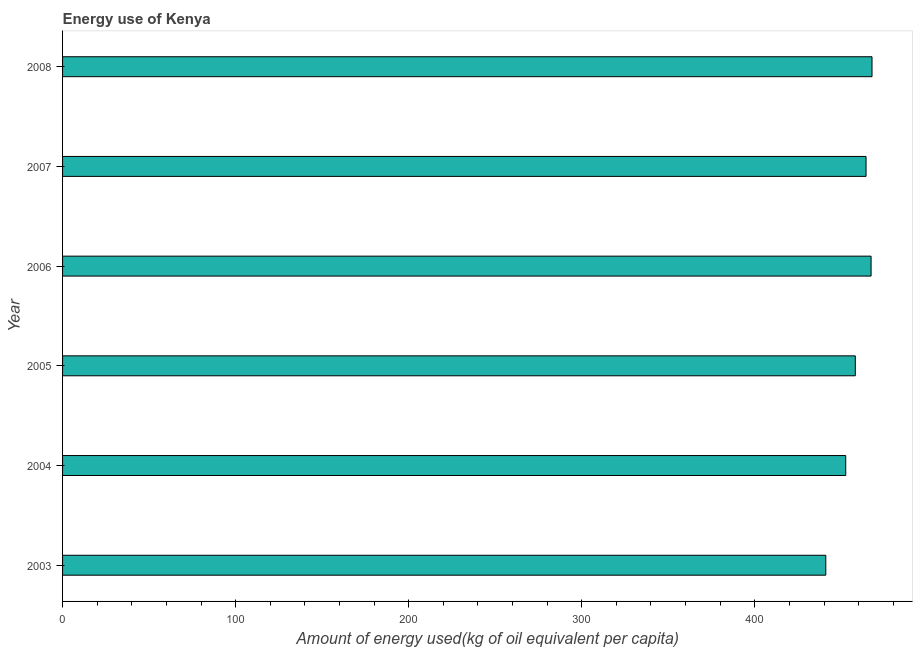What is the title of the graph?
Keep it short and to the point. Energy use of Kenya. What is the label or title of the X-axis?
Your answer should be very brief. Amount of energy used(kg of oil equivalent per capita). What is the amount of energy used in 2006?
Your answer should be very brief. 467.17. Across all years, what is the maximum amount of energy used?
Provide a short and direct response. 467.72. Across all years, what is the minimum amount of energy used?
Make the answer very short. 441.01. In which year was the amount of energy used maximum?
Your answer should be very brief. 2008. What is the sum of the amount of energy used?
Your answer should be compact. 2750.76. What is the difference between the amount of energy used in 2005 and 2008?
Ensure brevity in your answer.  -9.65. What is the average amount of energy used per year?
Offer a very short reply. 458.46. What is the median amount of energy used?
Offer a terse response. 461.17. What is the ratio of the amount of energy used in 2004 to that in 2005?
Provide a succinct answer. 0.99. Is the difference between the amount of energy used in 2003 and 2004 greater than the difference between any two years?
Your response must be concise. No. What is the difference between the highest and the second highest amount of energy used?
Your answer should be very brief. 0.55. Is the sum of the amount of energy used in 2005 and 2007 greater than the maximum amount of energy used across all years?
Keep it short and to the point. Yes. What is the difference between the highest and the lowest amount of energy used?
Provide a succinct answer. 26.71. How many years are there in the graph?
Make the answer very short. 6. Are the values on the major ticks of X-axis written in scientific E-notation?
Your answer should be very brief. No. What is the Amount of energy used(kg of oil equivalent per capita) in 2003?
Your response must be concise. 441.01. What is the Amount of energy used(kg of oil equivalent per capita) in 2004?
Keep it short and to the point. 452.53. What is the Amount of energy used(kg of oil equivalent per capita) of 2005?
Provide a short and direct response. 458.06. What is the Amount of energy used(kg of oil equivalent per capita) of 2006?
Your response must be concise. 467.17. What is the Amount of energy used(kg of oil equivalent per capita) of 2007?
Your answer should be very brief. 464.27. What is the Amount of energy used(kg of oil equivalent per capita) of 2008?
Provide a succinct answer. 467.72. What is the difference between the Amount of energy used(kg of oil equivalent per capita) in 2003 and 2004?
Provide a short and direct response. -11.52. What is the difference between the Amount of energy used(kg of oil equivalent per capita) in 2003 and 2005?
Your answer should be very brief. -17.05. What is the difference between the Amount of energy used(kg of oil equivalent per capita) in 2003 and 2006?
Provide a short and direct response. -26.16. What is the difference between the Amount of energy used(kg of oil equivalent per capita) in 2003 and 2007?
Your response must be concise. -23.26. What is the difference between the Amount of energy used(kg of oil equivalent per capita) in 2003 and 2008?
Ensure brevity in your answer.  -26.71. What is the difference between the Amount of energy used(kg of oil equivalent per capita) in 2004 and 2005?
Give a very brief answer. -5.54. What is the difference between the Amount of energy used(kg of oil equivalent per capita) in 2004 and 2006?
Give a very brief answer. -14.65. What is the difference between the Amount of energy used(kg of oil equivalent per capita) in 2004 and 2007?
Give a very brief answer. -11.74. What is the difference between the Amount of energy used(kg of oil equivalent per capita) in 2004 and 2008?
Make the answer very short. -15.19. What is the difference between the Amount of energy used(kg of oil equivalent per capita) in 2005 and 2006?
Ensure brevity in your answer.  -9.11. What is the difference between the Amount of energy used(kg of oil equivalent per capita) in 2005 and 2007?
Make the answer very short. -6.2. What is the difference between the Amount of energy used(kg of oil equivalent per capita) in 2005 and 2008?
Provide a succinct answer. -9.65. What is the difference between the Amount of energy used(kg of oil equivalent per capita) in 2006 and 2007?
Offer a very short reply. 2.9. What is the difference between the Amount of energy used(kg of oil equivalent per capita) in 2006 and 2008?
Give a very brief answer. -0.54. What is the difference between the Amount of energy used(kg of oil equivalent per capita) in 2007 and 2008?
Provide a succinct answer. -3.45. What is the ratio of the Amount of energy used(kg of oil equivalent per capita) in 2003 to that in 2006?
Ensure brevity in your answer.  0.94. What is the ratio of the Amount of energy used(kg of oil equivalent per capita) in 2003 to that in 2007?
Your answer should be compact. 0.95. What is the ratio of the Amount of energy used(kg of oil equivalent per capita) in 2003 to that in 2008?
Ensure brevity in your answer.  0.94. What is the ratio of the Amount of energy used(kg of oil equivalent per capita) in 2004 to that in 2005?
Your response must be concise. 0.99. What is the ratio of the Amount of energy used(kg of oil equivalent per capita) in 2004 to that in 2006?
Keep it short and to the point. 0.97. What is the ratio of the Amount of energy used(kg of oil equivalent per capita) in 2004 to that in 2008?
Your response must be concise. 0.97. What is the ratio of the Amount of energy used(kg of oil equivalent per capita) in 2005 to that in 2006?
Ensure brevity in your answer.  0.98. What is the ratio of the Amount of energy used(kg of oil equivalent per capita) in 2005 to that in 2007?
Your response must be concise. 0.99. What is the ratio of the Amount of energy used(kg of oil equivalent per capita) in 2005 to that in 2008?
Your answer should be compact. 0.98. What is the ratio of the Amount of energy used(kg of oil equivalent per capita) in 2006 to that in 2008?
Make the answer very short. 1. 